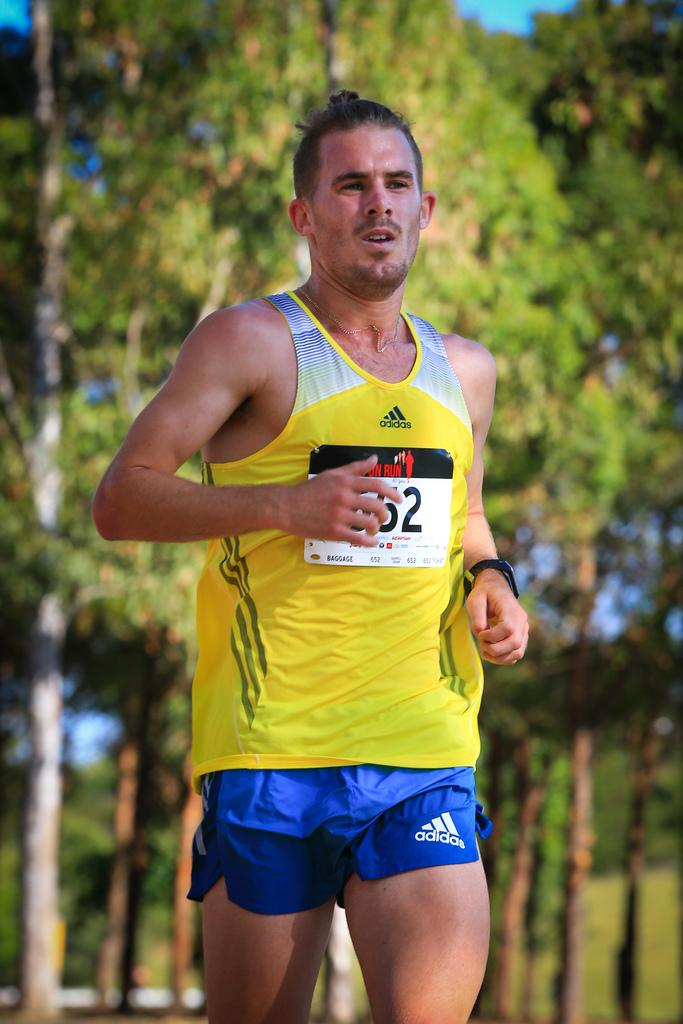<image>
Create a compact narrative representing the image presented. the number 52 that is on a person 